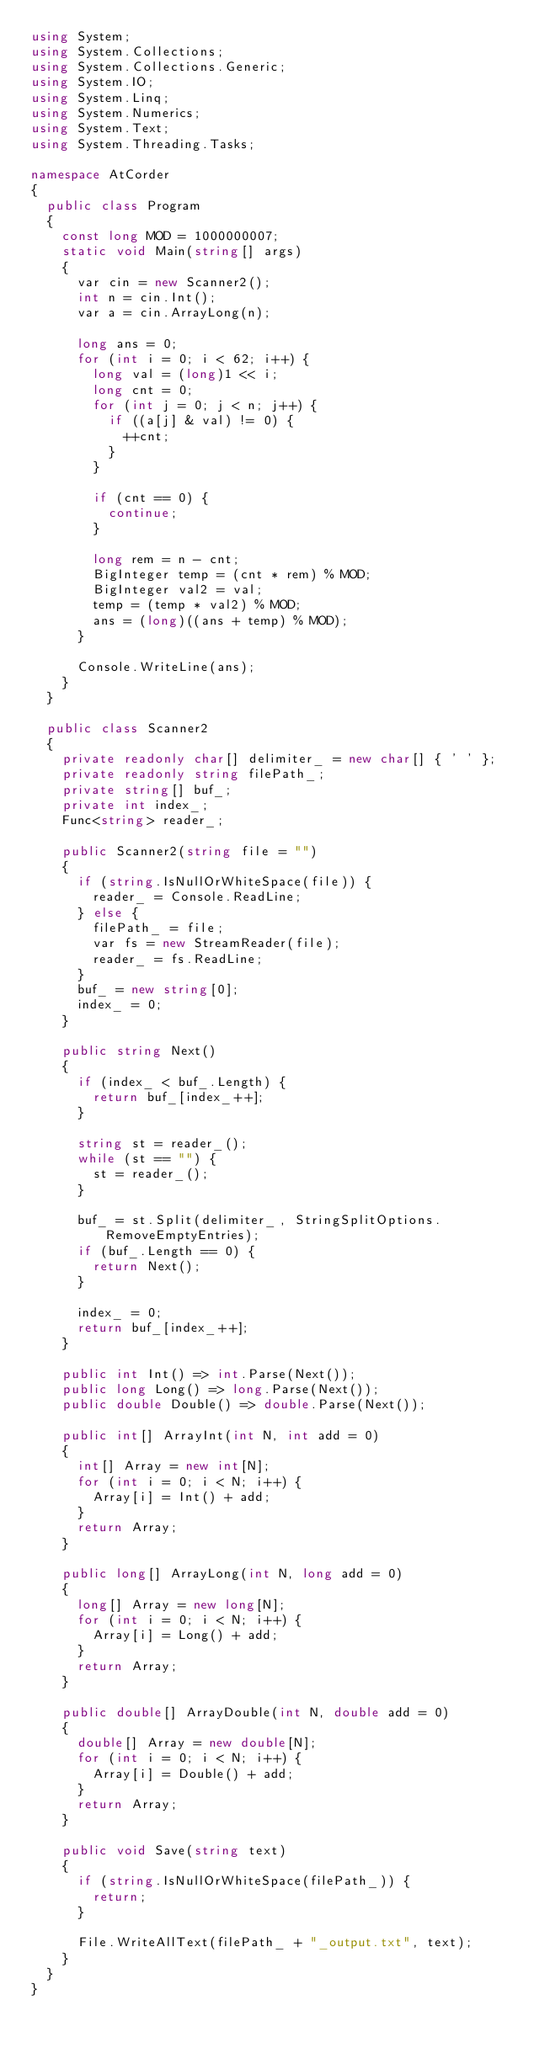<code> <loc_0><loc_0><loc_500><loc_500><_C#_>using System;
using System.Collections;
using System.Collections.Generic;
using System.IO;
using System.Linq;
using System.Numerics;
using System.Text;
using System.Threading.Tasks;

namespace AtCorder
{
	public class Program
	{
		const long MOD = 1000000007;
		static void Main(string[] args)
		{
			var cin = new Scanner2();
			int n = cin.Int();
			var a = cin.ArrayLong(n);

			long ans = 0;
			for (int i = 0; i < 62; i++) {
				long val = (long)1 << i;
				long cnt = 0;
				for (int j = 0; j < n; j++) {
					if ((a[j] & val) != 0) {
						++cnt;
					}
				}

				if (cnt == 0) {
					continue;
				}

				long rem = n - cnt;
				BigInteger temp = (cnt * rem) % MOD;
				BigInteger val2 = val;
				temp = (temp * val2) % MOD;
				ans = (long)((ans + temp) % MOD);
			}

			Console.WriteLine(ans);
		}
	}

	public class Scanner2
	{
		private readonly char[] delimiter_ = new char[] { ' ' };
		private readonly string filePath_;
		private string[] buf_;
		private int index_;
		Func<string> reader_;

		public Scanner2(string file = "")
		{
			if (string.IsNullOrWhiteSpace(file)) {
				reader_ = Console.ReadLine;
			} else {
				filePath_ = file;
				var fs = new StreamReader(file);
				reader_ = fs.ReadLine;
			}
			buf_ = new string[0];
			index_ = 0;
		}

		public string Next()
		{
			if (index_ < buf_.Length) {
				return buf_[index_++];
			}

			string st = reader_();
			while (st == "") {
				st = reader_();
			}

			buf_ = st.Split(delimiter_, StringSplitOptions.RemoveEmptyEntries);
			if (buf_.Length == 0) {
				return Next();
			}

			index_ = 0;
			return buf_[index_++];
		}

		public int Int() => int.Parse(Next());
		public long Long() => long.Parse(Next());
		public double Double() => double.Parse(Next());

		public int[] ArrayInt(int N, int add = 0)
		{
			int[] Array = new int[N];
			for (int i = 0; i < N; i++) {
				Array[i] = Int() + add;
			}
			return Array;
		}

		public long[] ArrayLong(int N, long add = 0)
		{
			long[] Array = new long[N];
			for (int i = 0; i < N; i++) {
				Array[i] = Long() + add;
			}
			return Array;
		}

		public double[] ArrayDouble(int N, double add = 0)
		{
			double[] Array = new double[N];
			for (int i = 0; i < N; i++) {
				Array[i] = Double() + add;
			}
			return Array;
		}

		public void Save(string text)
		{
			if (string.IsNullOrWhiteSpace(filePath_)) {
				return;
			}

			File.WriteAllText(filePath_ + "_output.txt", text);
		}
	}
}</code> 